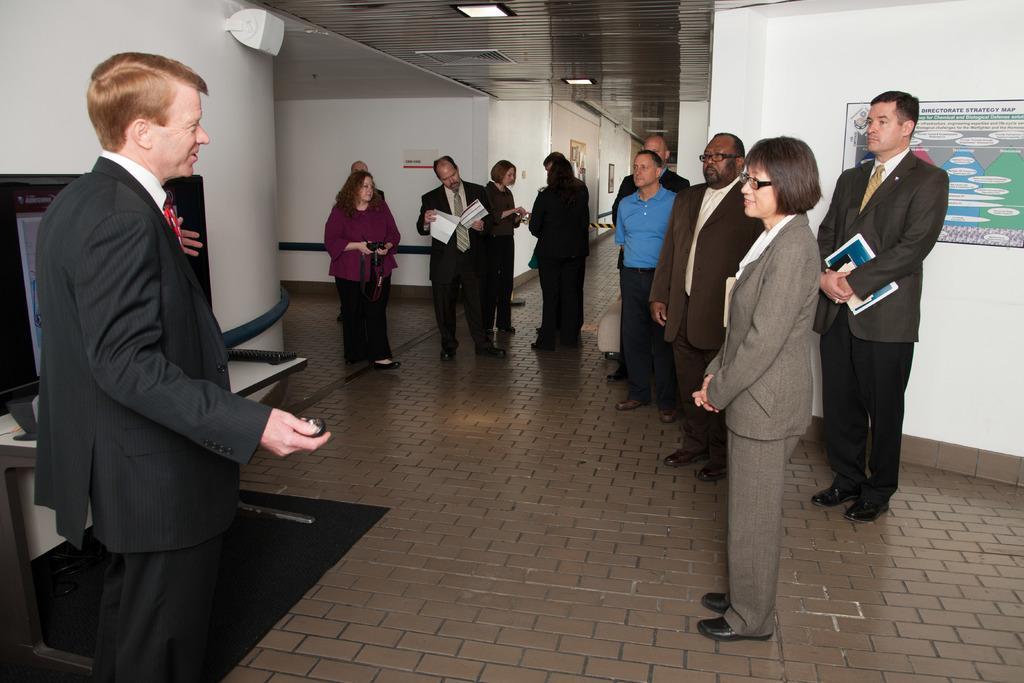Please provide a concise description of this image. In this image there are group of persons standing, they are holding an object, there is a man standing towards the bottom of the image, he is holding an object, he is talking, there is floor towards the bottom of the image, there are objects on the floor, there is a wall, there are objects on the wall, there is an object towards the left of the image, there is a roof towards the top of the image, there are lights. 